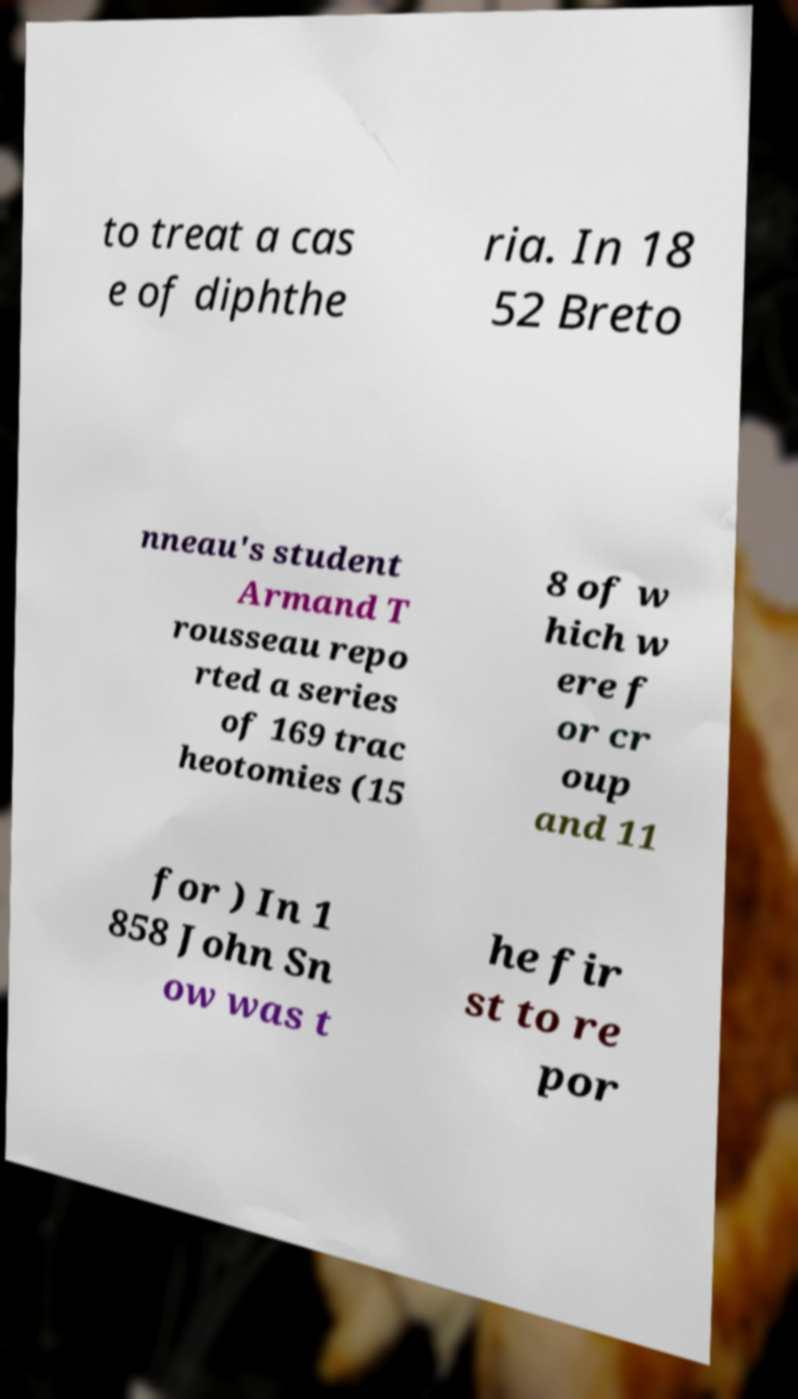I need the written content from this picture converted into text. Can you do that? to treat a cas e of diphthe ria. In 18 52 Breto nneau's student Armand T rousseau repo rted a series of 169 trac heotomies (15 8 of w hich w ere f or cr oup and 11 for ) In 1 858 John Sn ow was t he fir st to re por 